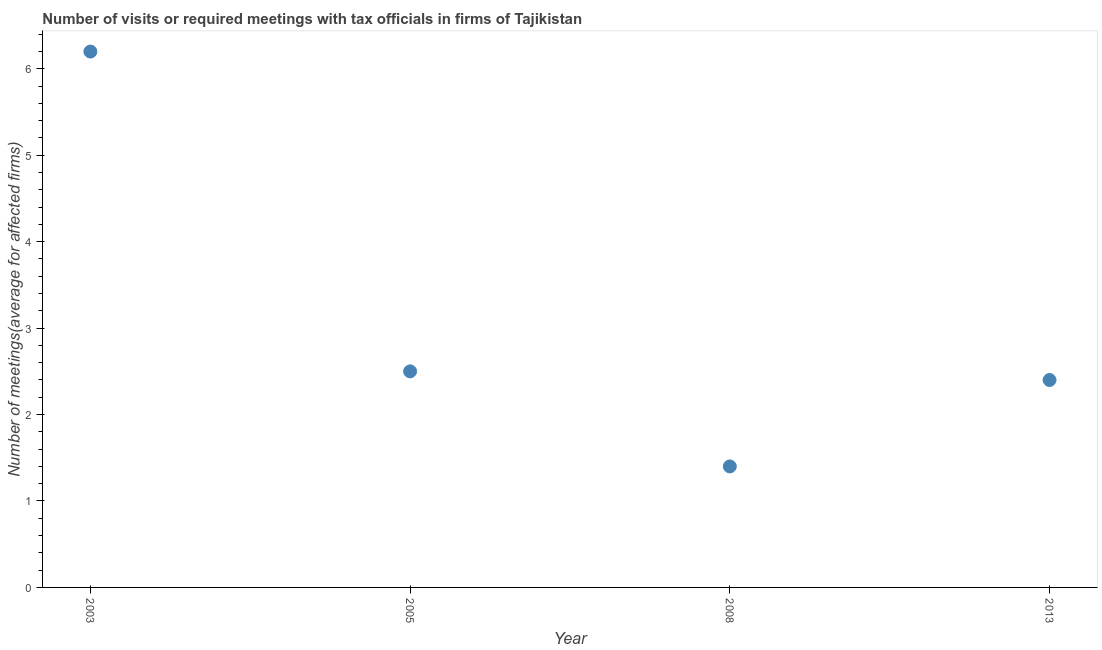Across all years, what is the minimum number of required meetings with tax officials?
Offer a terse response. 1.4. In which year was the number of required meetings with tax officials maximum?
Your answer should be compact. 2003. What is the difference between the number of required meetings with tax officials in 2003 and 2013?
Ensure brevity in your answer.  3.8. What is the average number of required meetings with tax officials per year?
Make the answer very short. 3.12. What is the median number of required meetings with tax officials?
Make the answer very short. 2.45. In how many years, is the number of required meetings with tax officials greater than 0.4 ?
Make the answer very short. 4. What is the ratio of the number of required meetings with tax officials in 2003 to that in 2008?
Provide a succinct answer. 4.43. Is the difference between the number of required meetings with tax officials in 2005 and 2008 greater than the difference between any two years?
Your answer should be very brief. No. What is the difference between the highest and the second highest number of required meetings with tax officials?
Provide a short and direct response. 3.7. Is the sum of the number of required meetings with tax officials in 2003 and 2005 greater than the maximum number of required meetings with tax officials across all years?
Offer a terse response. Yes. What is the difference between the highest and the lowest number of required meetings with tax officials?
Your answer should be very brief. 4.8. In how many years, is the number of required meetings with tax officials greater than the average number of required meetings with tax officials taken over all years?
Make the answer very short. 1. How many dotlines are there?
Your answer should be compact. 1. What is the title of the graph?
Ensure brevity in your answer.  Number of visits or required meetings with tax officials in firms of Tajikistan. What is the label or title of the X-axis?
Make the answer very short. Year. What is the label or title of the Y-axis?
Give a very brief answer. Number of meetings(average for affected firms). What is the Number of meetings(average for affected firms) in 2003?
Your response must be concise. 6.2. What is the difference between the Number of meetings(average for affected firms) in 2005 and 2008?
Offer a terse response. 1.1. What is the difference between the Number of meetings(average for affected firms) in 2008 and 2013?
Provide a succinct answer. -1. What is the ratio of the Number of meetings(average for affected firms) in 2003 to that in 2005?
Make the answer very short. 2.48. What is the ratio of the Number of meetings(average for affected firms) in 2003 to that in 2008?
Offer a terse response. 4.43. What is the ratio of the Number of meetings(average for affected firms) in 2003 to that in 2013?
Keep it short and to the point. 2.58. What is the ratio of the Number of meetings(average for affected firms) in 2005 to that in 2008?
Give a very brief answer. 1.79. What is the ratio of the Number of meetings(average for affected firms) in 2005 to that in 2013?
Provide a succinct answer. 1.04. What is the ratio of the Number of meetings(average for affected firms) in 2008 to that in 2013?
Offer a terse response. 0.58. 